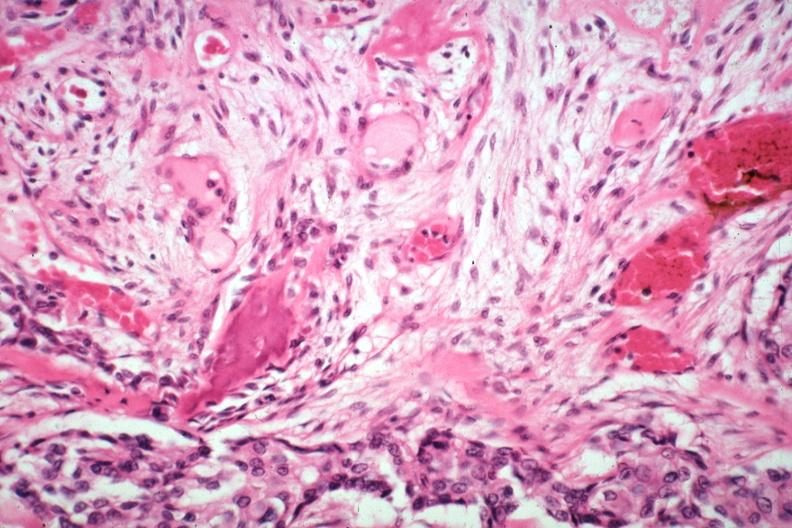what is present?
Answer the question using a single word or phrase. Joints 